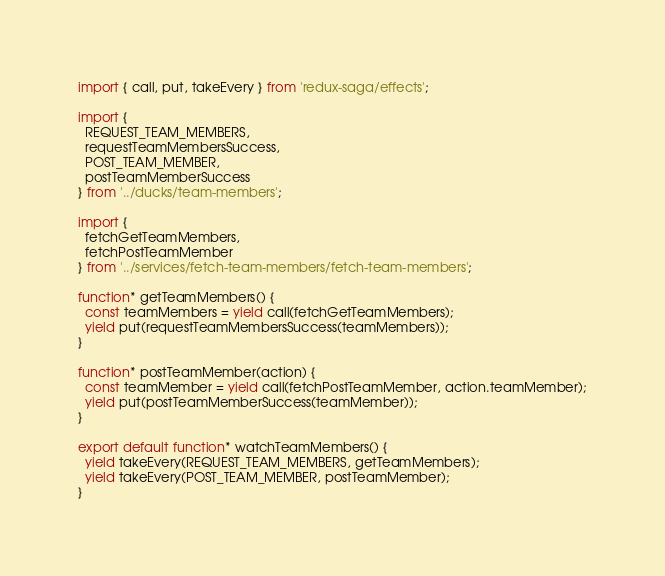<code> <loc_0><loc_0><loc_500><loc_500><_JavaScript_>import { call, put, takeEvery } from 'redux-saga/effects';

import {
  REQUEST_TEAM_MEMBERS,
  requestTeamMembersSuccess,
  POST_TEAM_MEMBER,
  postTeamMemberSuccess
} from '../ducks/team-members';

import {
  fetchGetTeamMembers,
  fetchPostTeamMember
} from '../services/fetch-team-members/fetch-team-members';

function* getTeamMembers() {
  const teamMembers = yield call(fetchGetTeamMembers);
  yield put(requestTeamMembersSuccess(teamMembers));
}

function* postTeamMember(action) {
  const teamMember = yield call(fetchPostTeamMember, action.teamMember);
  yield put(postTeamMemberSuccess(teamMember));
}

export default function* watchTeamMembers() {
  yield takeEvery(REQUEST_TEAM_MEMBERS, getTeamMembers);
  yield takeEvery(POST_TEAM_MEMBER, postTeamMember);
}
</code> 